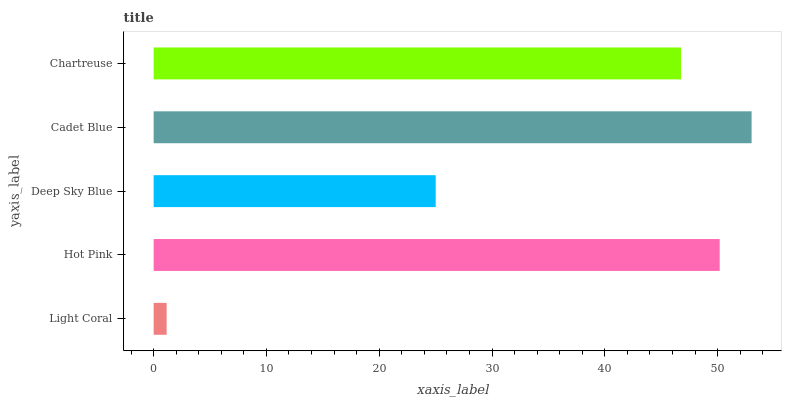Is Light Coral the minimum?
Answer yes or no. Yes. Is Cadet Blue the maximum?
Answer yes or no. Yes. Is Hot Pink the minimum?
Answer yes or no. No. Is Hot Pink the maximum?
Answer yes or no. No. Is Hot Pink greater than Light Coral?
Answer yes or no. Yes. Is Light Coral less than Hot Pink?
Answer yes or no. Yes. Is Light Coral greater than Hot Pink?
Answer yes or no. No. Is Hot Pink less than Light Coral?
Answer yes or no. No. Is Chartreuse the high median?
Answer yes or no. Yes. Is Chartreuse the low median?
Answer yes or no. Yes. Is Hot Pink the high median?
Answer yes or no. No. Is Hot Pink the low median?
Answer yes or no. No. 